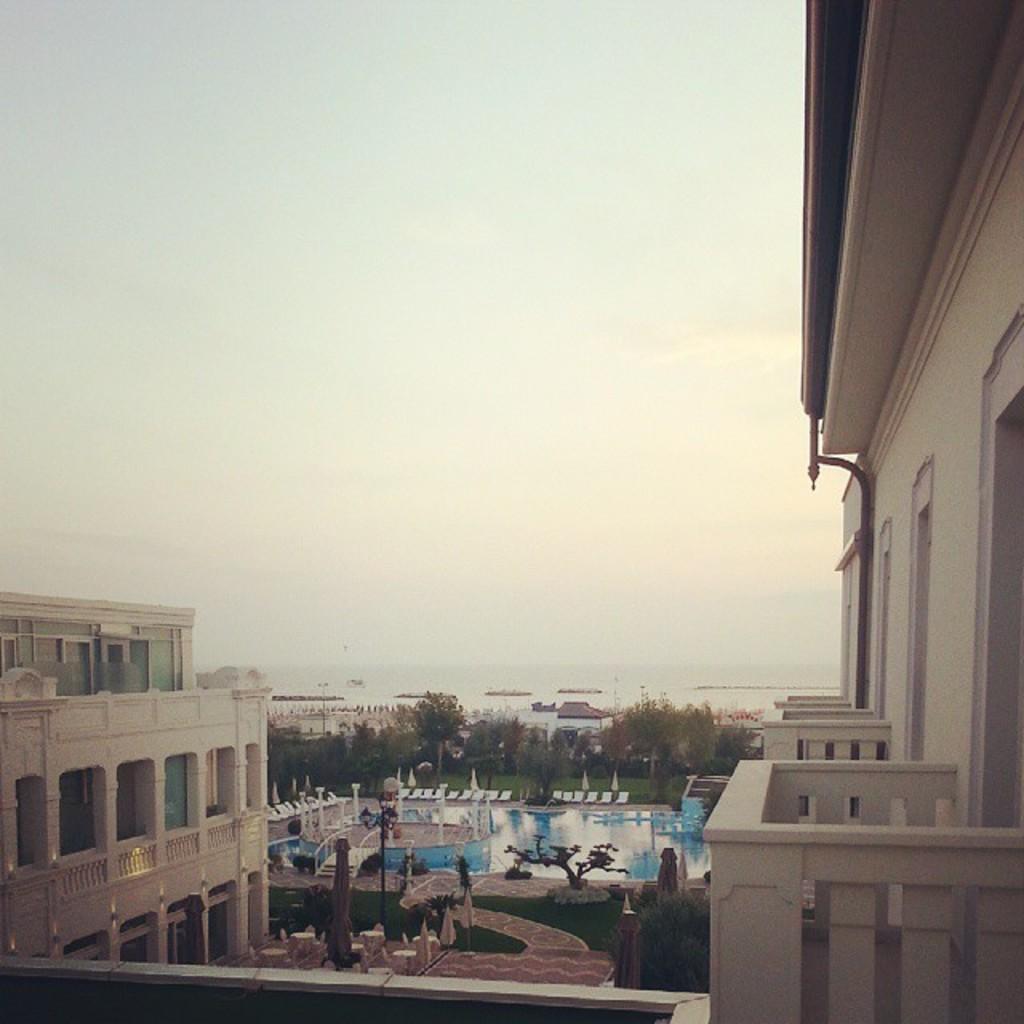In one or two sentences, can you explain what this image depicts? This image is taken from the top of the building. In the middle we can see a swimming pool. On the left side there is a building. At the top there is the sky. Beside the swimming pool there are trees. On the right side there is another building. At the bottom there is ground on which there is grass. 